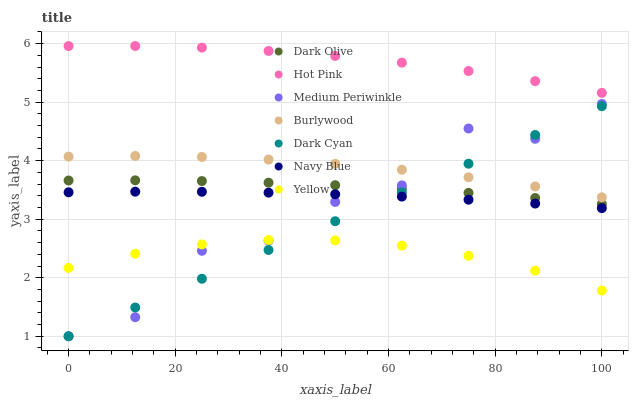Does Yellow have the minimum area under the curve?
Answer yes or no. Yes. Does Hot Pink have the maximum area under the curve?
Answer yes or no. Yes. Does Burlywood have the minimum area under the curve?
Answer yes or no. No. Does Burlywood have the maximum area under the curve?
Answer yes or no. No. Is Dark Cyan the smoothest?
Answer yes or no. Yes. Is Medium Periwinkle the roughest?
Answer yes or no. Yes. Is Burlywood the smoothest?
Answer yes or no. No. Is Burlywood the roughest?
Answer yes or no. No. Does Medium Periwinkle have the lowest value?
Answer yes or no. Yes. Does Burlywood have the lowest value?
Answer yes or no. No. Does Hot Pink have the highest value?
Answer yes or no. Yes. Does Burlywood have the highest value?
Answer yes or no. No. Is Navy Blue less than Hot Pink?
Answer yes or no. Yes. Is Dark Olive greater than Navy Blue?
Answer yes or no. Yes. Does Dark Cyan intersect Medium Periwinkle?
Answer yes or no. Yes. Is Dark Cyan less than Medium Periwinkle?
Answer yes or no. No. Is Dark Cyan greater than Medium Periwinkle?
Answer yes or no. No. Does Navy Blue intersect Hot Pink?
Answer yes or no. No. 